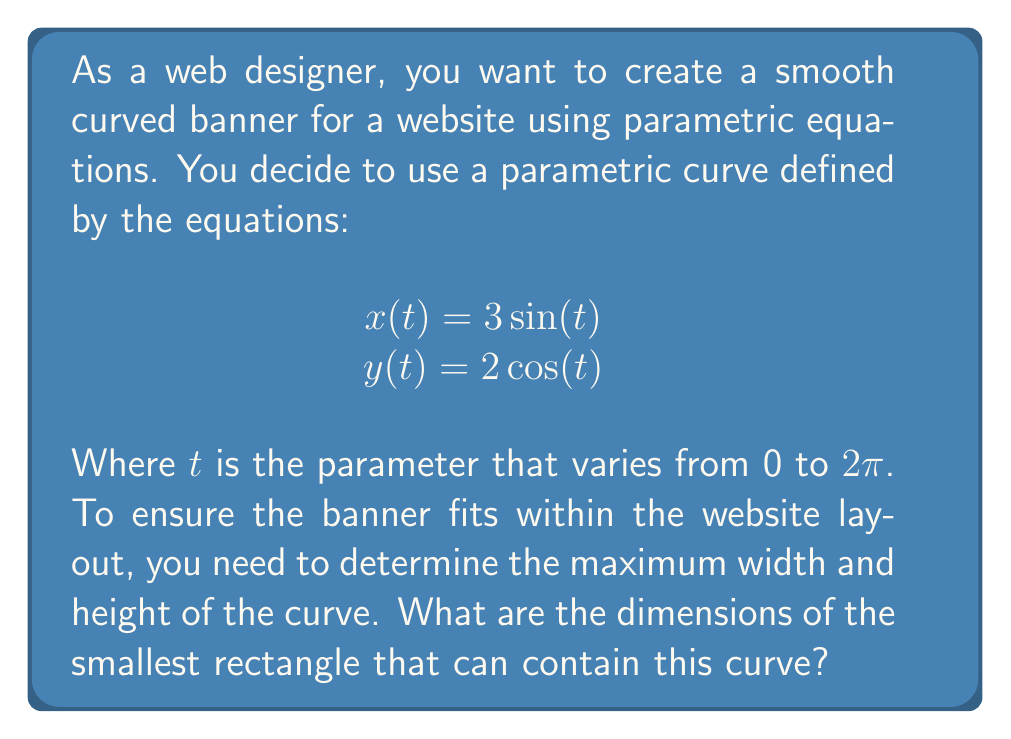Teach me how to tackle this problem. To find the dimensions of the smallest rectangle that can contain this curve, we need to determine the maximum and minimum values of x and y.

1. For the x-coordinate:
   $$x(t) = 3\sin(t)$$
   The sine function has a range of [-1, 1], so:
   $$-3 \leq x \leq 3$$
   The width of the rectangle is the difference between the maximum and minimum x values:
   $$\text{Width} = 3 - (-3) = 6$$

2. For the y-coordinate:
   $$y(t) = 2\cos(t)$$
   The cosine function has a range of [-1, 1], so:
   $$-2 \leq y \leq 2$$
   The height of the rectangle is the difference between the maximum and minimum y values:
   $$\text{Height} = 2 - (-2) = 4$$

Therefore, the smallest rectangle that can contain this curve has a width of 6 units and a height of 4 units.

[asy]
import graph;
size(200);
real xmin = -3.5, xmax = 3.5, ymin = -2.5, ymax = 2.5;
axes("x", "y", xmin, xmax, ymin, ymax, Arrow);

pen curvepen = rgb(0,0.5,0.5)+1;
pen rectpen = rgb(0.8,0,0)+dashed;

parametric("3*sin(t)","2*cos(t)",0,2pi,operator ..,curvepen);

draw((3,2)--(3,-2)--(-3,-2)--(-3,2)--cycle, rectpen);

label("6", (0,-2.2), S);
label("4", (3.2,0), E);
[/asy]
Answer: The dimensions of the smallest rectangle that can contain the curve are 6 units wide and 4 units high. 